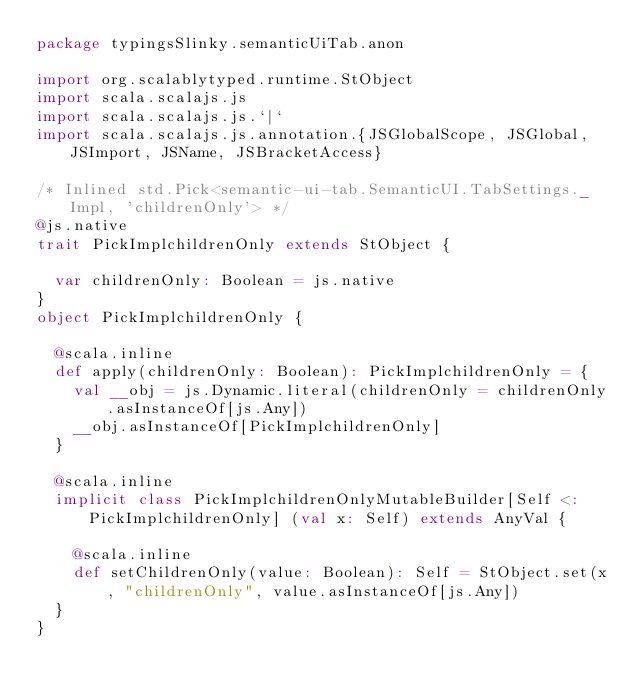Convert code to text. <code><loc_0><loc_0><loc_500><loc_500><_Scala_>package typingsSlinky.semanticUiTab.anon

import org.scalablytyped.runtime.StObject
import scala.scalajs.js
import scala.scalajs.js.`|`
import scala.scalajs.js.annotation.{JSGlobalScope, JSGlobal, JSImport, JSName, JSBracketAccess}

/* Inlined std.Pick<semantic-ui-tab.SemanticUI.TabSettings._Impl, 'childrenOnly'> */
@js.native
trait PickImplchildrenOnly extends StObject {
  
  var childrenOnly: Boolean = js.native
}
object PickImplchildrenOnly {
  
  @scala.inline
  def apply(childrenOnly: Boolean): PickImplchildrenOnly = {
    val __obj = js.Dynamic.literal(childrenOnly = childrenOnly.asInstanceOf[js.Any])
    __obj.asInstanceOf[PickImplchildrenOnly]
  }
  
  @scala.inline
  implicit class PickImplchildrenOnlyMutableBuilder[Self <: PickImplchildrenOnly] (val x: Self) extends AnyVal {
    
    @scala.inline
    def setChildrenOnly(value: Boolean): Self = StObject.set(x, "childrenOnly", value.asInstanceOf[js.Any])
  }
}
</code> 